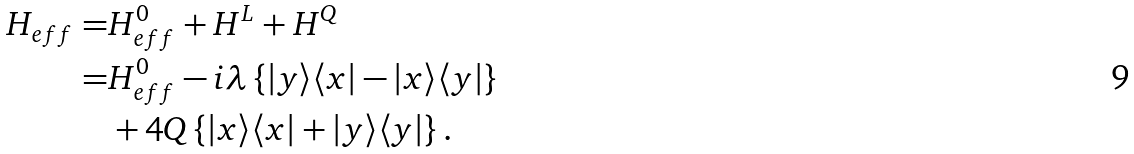<formula> <loc_0><loc_0><loc_500><loc_500>H _ { e f f } = & H _ { e f f } ^ { 0 } + H ^ { L } + H ^ { Q } \\ = & H _ { e f f } ^ { 0 } - i \lambda \left \{ | y \rangle \langle x | - | x \rangle \langle y | \right \} \\ & + 4 Q \left \{ | x \rangle \langle x | + | y \rangle \langle y | \right \} .</formula> 